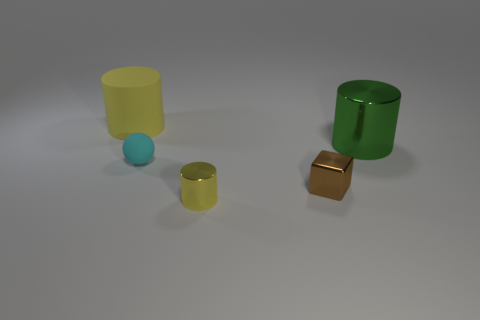Add 2 tiny cyan rubber things. How many objects exist? 7 Subtract all cylinders. How many objects are left? 2 Add 4 small blue rubber cubes. How many small blue rubber cubes exist? 4 Subtract 0 red cylinders. How many objects are left? 5 Subtract all red metallic cylinders. Subtract all metallic cylinders. How many objects are left? 3 Add 5 shiny cylinders. How many shiny cylinders are left? 7 